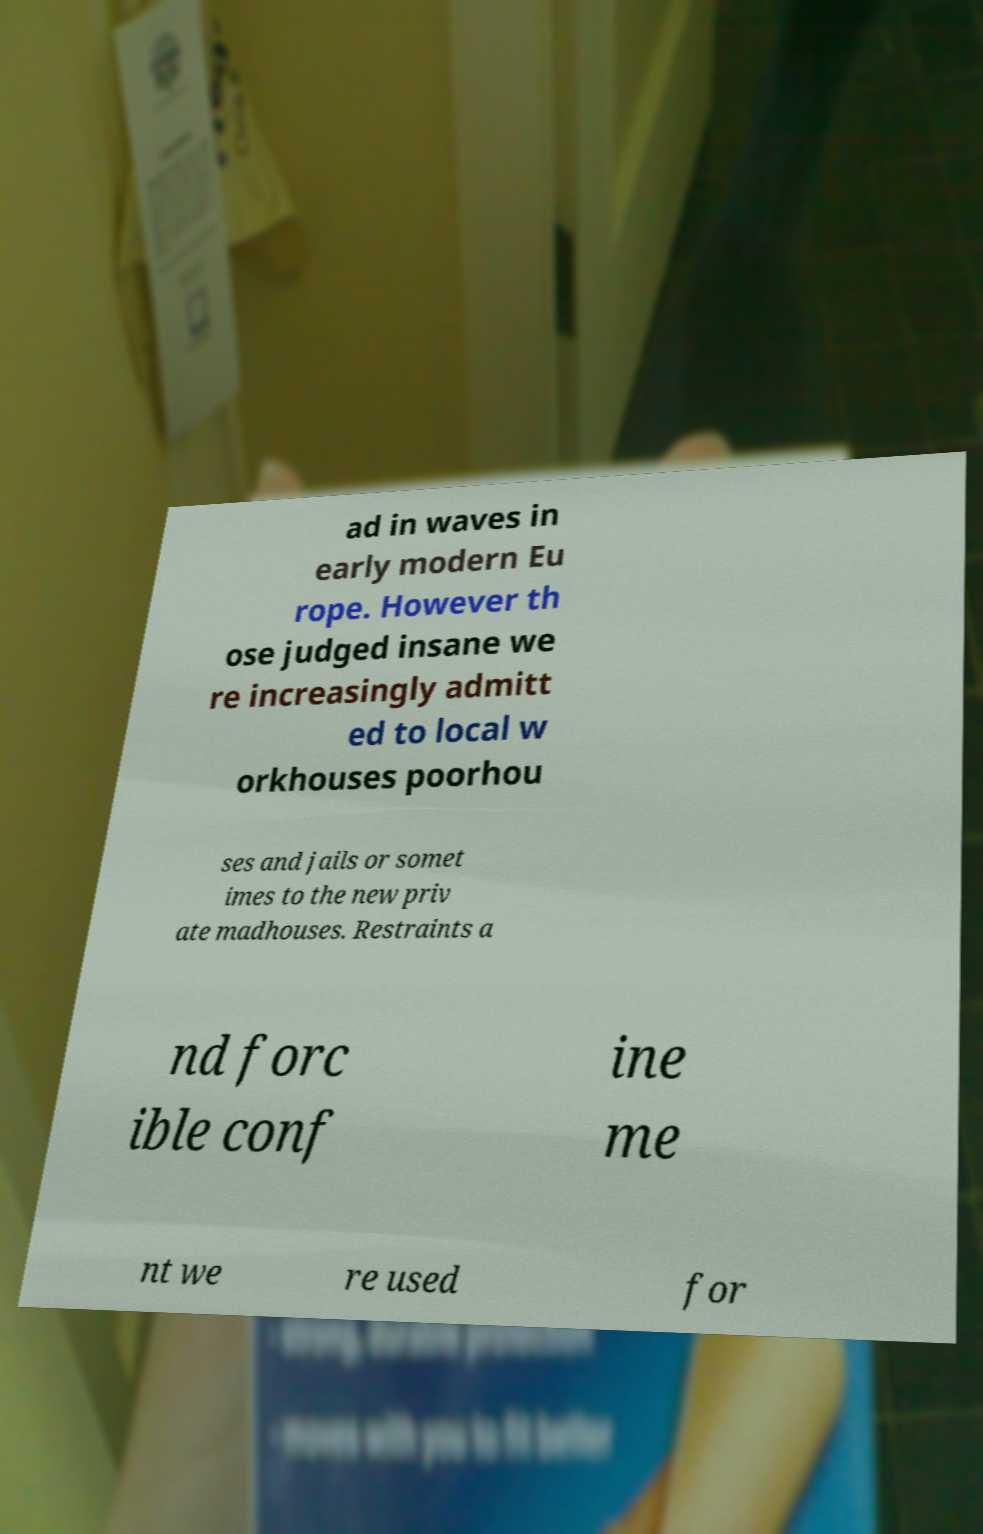What messages or text are displayed in this image? I need them in a readable, typed format. ad in waves in early modern Eu rope. However th ose judged insane we re increasingly admitt ed to local w orkhouses poorhou ses and jails or somet imes to the new priv ate madhouses. Restraints a nd forc ible conf ine me nt we re used for 